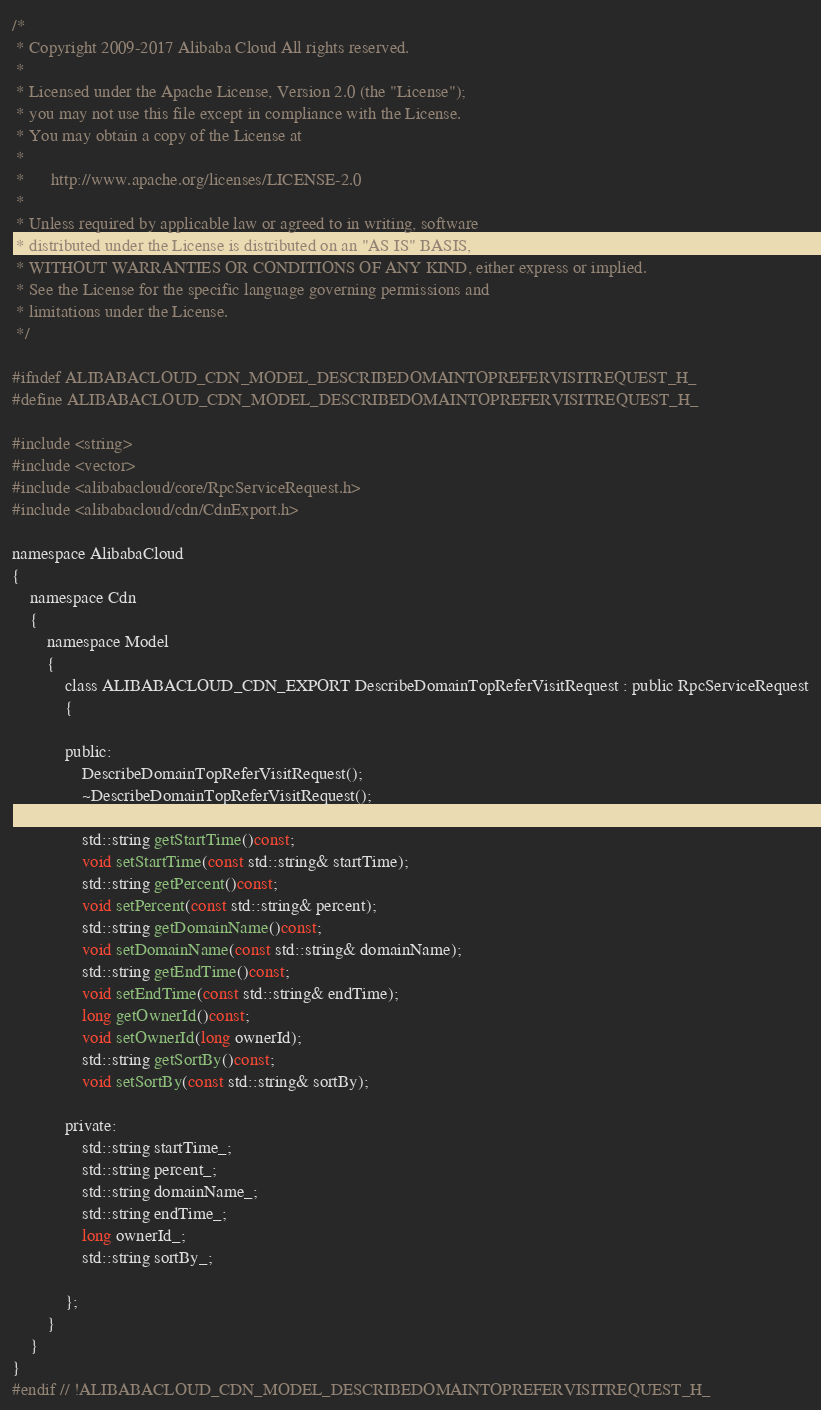<code> <loc_0><loc_0><loc_500><loc_500><_C_>/*
 * Copyright 2009-2017 Alibaba Cloud All rights reserved.
 * 
 * Licensed under the Apache License, Version 2.0 (the "License");
 * you may not use this file except in compliance with the License.
 * You may obtain a copy of the License at
 * 
 *      http://www.apache.org/licenses/LICENSE-2.0
 * 
 * Unless required by applicable law or agreed to in writing, software
 * distributed under the License is distributed on an "AS IS" BASIS,
 * WITHOUT WARRANTIES OR CONDITIONS OF ANY KIND, either express or implied.
 * See the License for the specific language governing permissions and
 * limitations under the License.
 */

#ifndef ALIBABACLOUD_CDN_MODEL_DESCRIBEDOMAINTOPREFERVISITREQUEST_H_
#define ALIBABACLOUD_CDN_MODEL_DESCRIBEDOMAINTOPREFERVISITREQUEST_H_

#include <string>
#include <vector>
#include <alibabacloud/core/RpcServiceRequest.h>
#include <alibabacloud/cdn/CdnExport.h>

namespace AlibabaCloud
{
	namespace Cdn
	{
		namespace Model
		{
			class ALIBABACLOUD_CDN_EXPORT DescribeDomainTopReferVisitRequest : public RpcServiceRequest
			{

			public:
				DescribeDomainTopReferVisitRequest();
				~DescribeDomainTopReferVisitRequest();

				std::string getStartTime()const;
				void setStartTime(const std::string& startTime);
				std::string getPercent()const;
				void setPercent(const std::string& percent);
				std::string getDomainName()const;
				void setDomainName(const std::string& domainName);
				std::string getEndTime()const;
				void setEndTime(const std::string& endTime);
				long getOwnerId()const;
				void setOwnerId(long ownerId);
				std::string getSortBy()const;
				void setSortBy(const std::string& sortBy);

            private:
				std::string startTime_;
				std::string percent_;
				std::string domainName_;
				std::string endTime_;
				long ownerId_;
				std::string sortBy_;

			};
		}
	}
}
#endif // !ALIBABACLOUD_CDN_MODEL_DESCRIBEDOMAINTOPREFERVISITREQUEST_H_</code> 